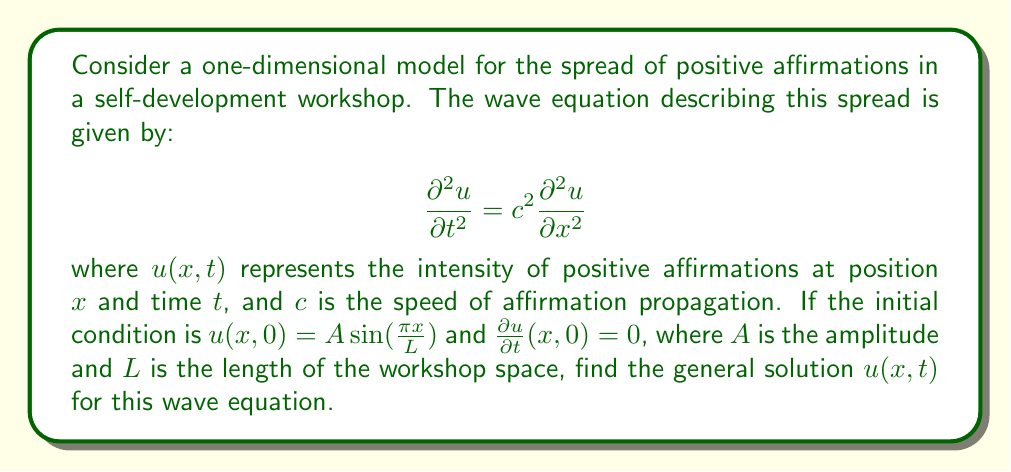Provide a solution to this math problem. To solve this wave equation, we'll follow these steps:

1) The general solution for a wave equation with these initial conditions is of the form:

   $$u(x,t) = F(x-ct) + G(x+ct)$$

2) Given the initial condition $u(x,0) = A \sin(\frac{\pi x}{L})$, we can deduce:

   $$F(x) + G(x) = A \sin(\frac{\pi x}{L})$$

3) The second initial condition $\frac{\partial u}{\partial t}(x,0) = 0$ implies:

   $$-cF'(x) + cG'(x) = 0$$

   This means $F'(x) = G'(x)$, so $F(x) = G(x) + K$ where $K$ is a constant.

4) Substituting this back into the equation from step 2:

   $$2G(x) + K = A \sin(\frac{\pi x}{L})$$

   $$G(x) = \frac{A}{2} \sin(\frac{\pi x}{L}) - \frac{K}{2}$$

5) Since $K$ is an arbitrary constant, we can set it to zero for simplicity. Thus:

   $$F(x) = G(x) = \frac{A}{2} \sin(\frac{\pi x}{L})$$

6) Now, we can write the general solution:

   $$u(x,t) = \frac{A}{2} \sin(\frac{\pi (x-ct)}{L}) + \frac{A}{2} \sin(\frac{\pi (x+ct)}{L})$$

7) Using the trigonometric identity for the sum of sines, this simplifies to:

   $$u(x,t) = A \sin(\frac{\pi x}{L}) \cos(\frac{\pi ct}{L})$$

This is the general solution for the given wave equation and initial conditions.
Answer: $$u(x,t) = A \sin(\frac{\pi x}{L}) \cos(\frac{\pi ct}{L})$$ 